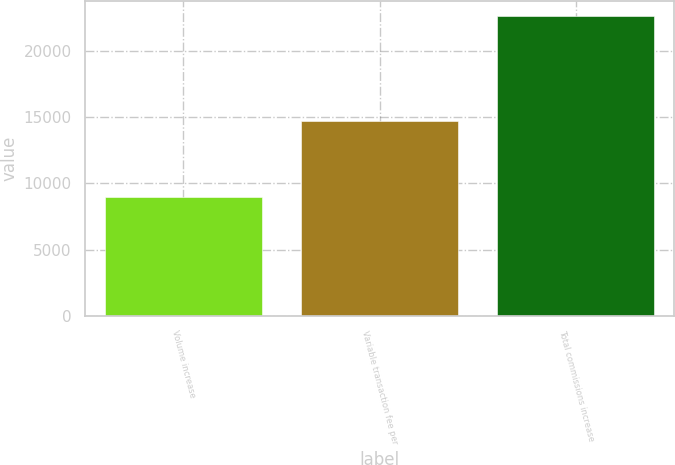<chart> <loc_0><loc_0><loc_500><loc_500><bar_chart><fcel>Volume increase<fcel>Variable transaction fee per<fcel>Total commissions increase<nl><fcel>8950<fcel>14727<fcel>22604<nl></chart> 